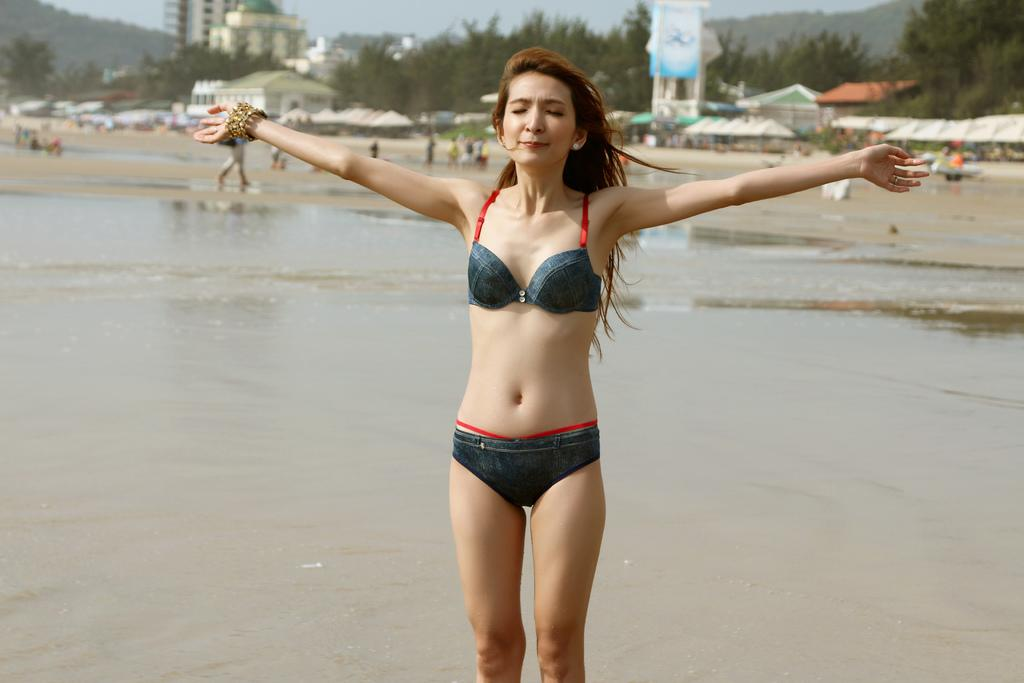What is the woman in the image doing? The woman is standing on a path in the image. What can be seen in the background of the image? There are people with umbrellas, trees, and buildings in the background of the image. What type of crow is perched on the woman's shoulder in the image? There is no crow present in the image; the woman is standing alone on the path. 